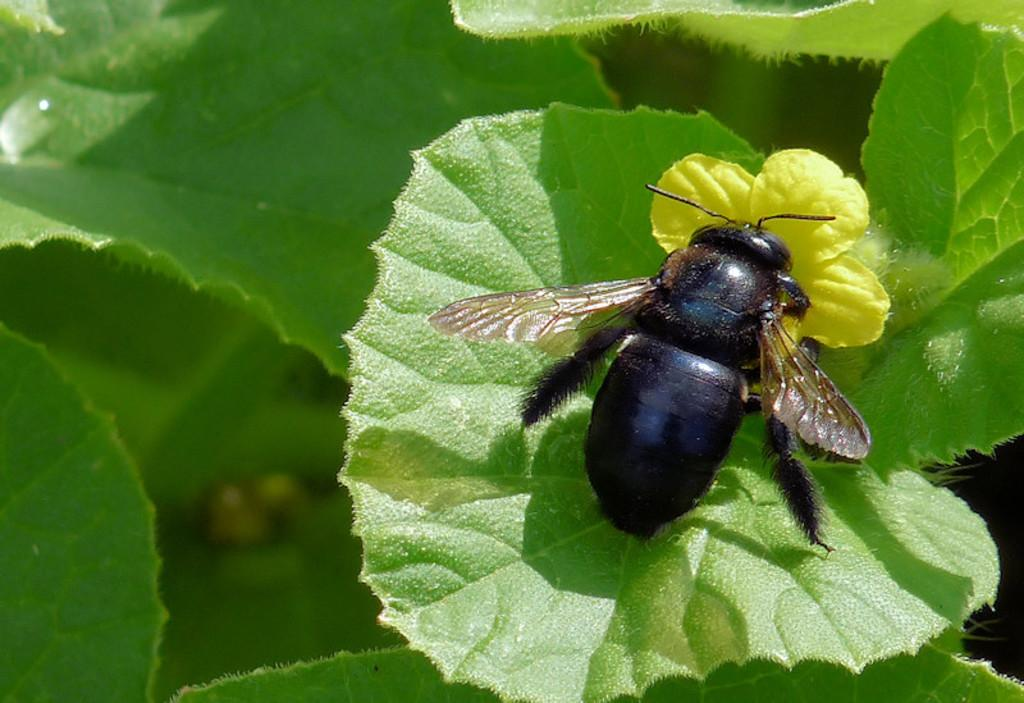What is the main subject of the image? There is a bee in the image. Where is the bee located in the image? The bee is sitting on a leaf. What type of flower can be seen in the image? There is a yellow color flower in the image. What can be seen in the background of the image? The background consists of leaves. What type of power source is visible in the image? There is no power source visible in the image; it features a bee sitting on a leaf and a yellow flower. Can you describe the bee's attempt to dig a hole in the image? There is no attempt by the bee to dig a hole in the image; it is simply sitting on a leaf. 